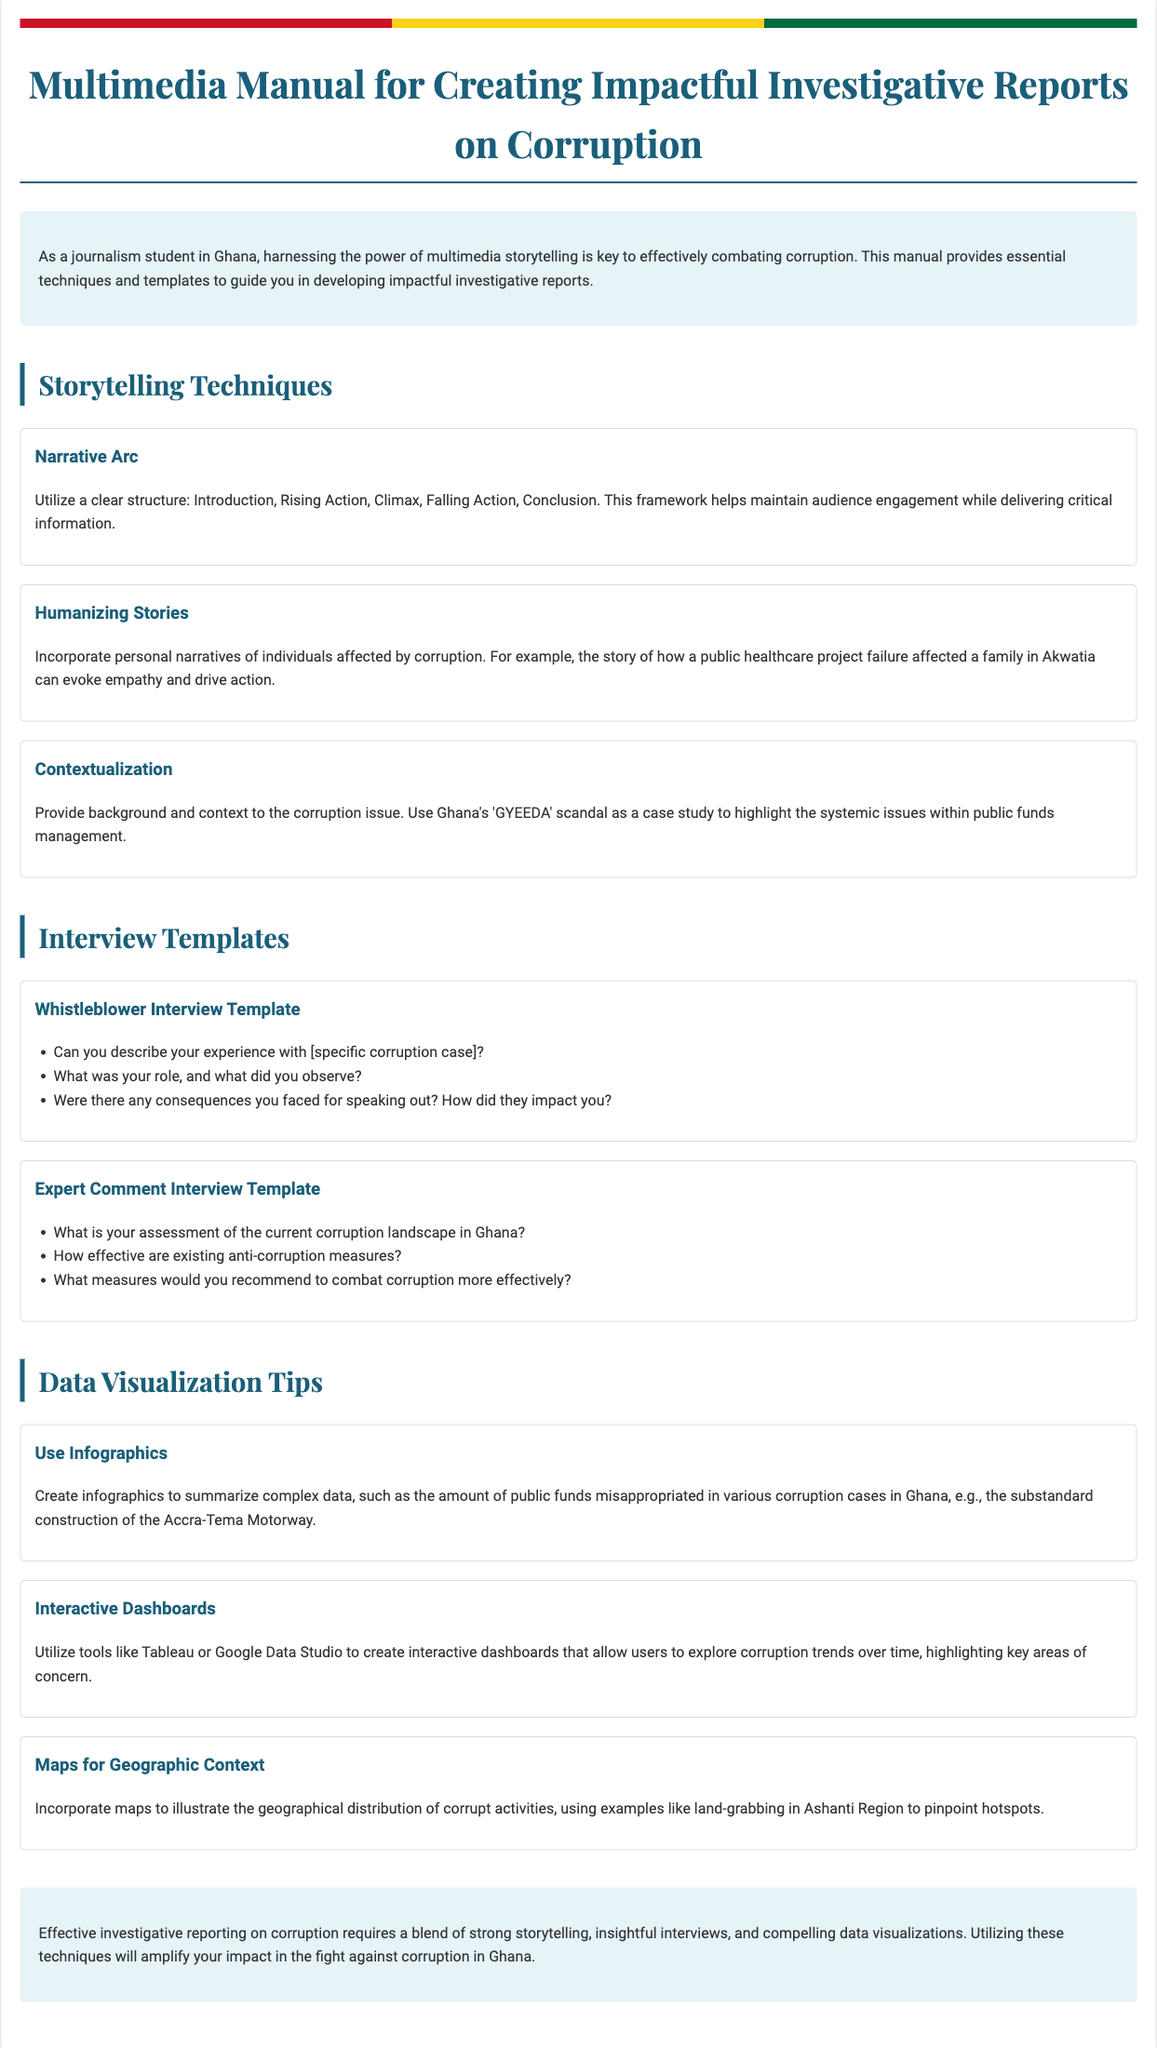What is the title of the manual? The title is stated at the top of the document in a prominent position.
Answer: Multimedia Manual for Creating Impactful Investigative Reports on Corruption What are the three stages in the narrative arc? The manual describes the narrative arc structure that consists of specific stages.
Answer: Introduction, Rising Action, Climax What is one example used to humanize stories? The document provides a specific example to illustrate the technique of humanizing stories.
Answer: A family in Akwatia What is a recommended tool for creating interactive dashboards? The manual suggests a specific tool for data visualization and interactivity.
Answer: Tableau What are the three types of interview templates provided? The document lists several types of templates, highlighting different focuses in interviews.
Answer: Whistleblower Interview Template, Expert Comment Interview Template What color is the background of the conclusion section? The document describes the visual appearance of different sections, including the conclusion.
Answer: Light blue What specific case study is mentioned for contextualization? The manual references a particular case that highlights larger systemic issues.
Answer: GYEEDA scandal How should infographics be used according to the manual? The manual provides guidance on the effective use of infographics in reporting.
Answer: Summarize complex data How do maps serve in the context of corruption reporting? The document explains the function and significance of maps in investigative reporting.
Answer: Illustrate geographical distribution of corrupt activities What is emphasized as essential for effective investigative reporting? The conclusion highlights key elements necessary for impactful reporting on corruption.
Answer: Strong storytelling, insightful interviews, compelling data visualizations 